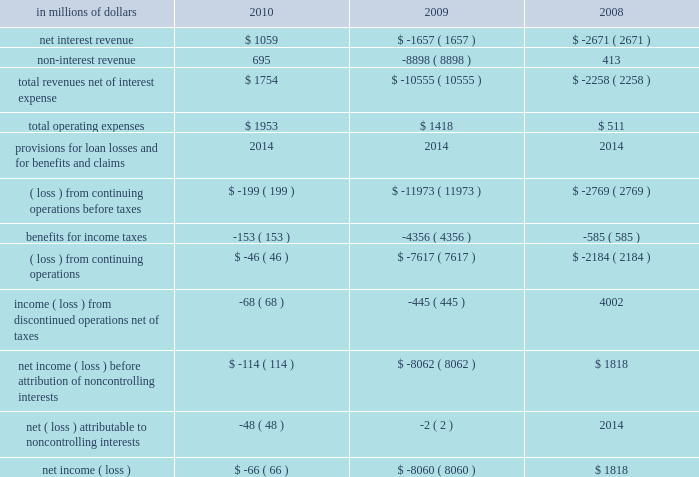Corporate/other corporate/other includes global staff functions ( including finance , risk , human resources , legal and compliance ) and other corporate expense , global operations and technology , residual corporate treasury and corporate items .
At december 31 , 2010 , this segment had approximately $ 272 billion of assets , consisting primarily of citi 2019s liquidity portfolio , including $ 87 billion of cash and deposits with banks. .
2010 vs .
2009 revenues , net of interest expense increased primarily due to the absence of the loss on debt extinguishment related to the repayment of the $ 20 billion of tarp trust preferred securities and the exit from the loss-sharing agreement with the u.s .
Government , each in the fourth quarter of 2009 .
Revenues also increased due to gains on sales of afs securities , benefits from lower short- term interest rates and other improved treasury results during the current year .
These increases were partially offset by the absence of the pretax gain related to citi 2019s public and private exchange offers in 2009 .
Operating expenses increased primarily due to various legal and related expenses , as well as other non-compensation expenses .
2009 vs .
2008 revenues , net of interest expense declined primarily due to the pretax loss on debt extinguishment related to the repayment of tarp and the exit from the loss-sharing agreement with the u.s .
Government .
Revenues also declined due to the absence of the 2008 sale of citigroup global services limited recorded in operations and technology .
These declines were partially offset by a pretax gain related to the exchange offers , revenues and higher intersegment eliminations .
Operating expenses increased primarily due to intersegment eliminations and increases in compensation , partially offset by lower repositioning reserves. .
What percent of total revenues net of interest expense was net interest revenue in 2010? 
Computations: (1059 / 1754)
Answer: 0.60376. 